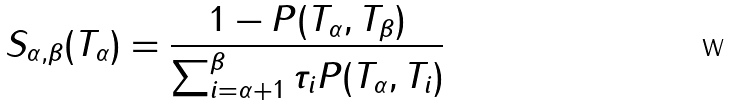<formula> <loc_0><loc_0><loc_500><loc_500>S _ { \alpha , \beta } ( T _ { \alpha } ) = \frac { 1 - P ( T _ { \alpha } , T _ { \beta } ) } { \sum _ { i = \alpha + 1 } ^ { \beta } \tau _ { i } P ( T _ { \alpha } , T _ { i } ) }</formula> 